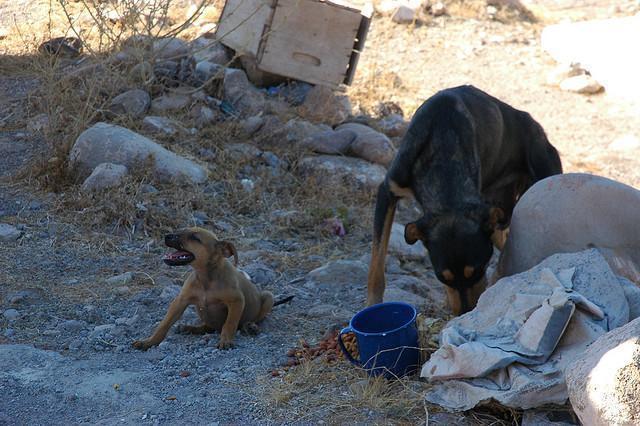How many dogs can be seen?
Give a very brief answer. 2. How many cups are in the picture?
Give a very brief answer. 1. How many dogs are there?
Give a very brief answer. 2. How many books are on the floor?
Give a very brief answer. 0. 